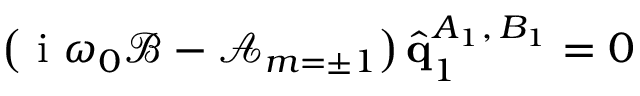Convert formula to latex. <formula><loc_0><loc_0><loc_500><loc_500>\left ( i \omega _ { 0 } \mathcal { B } - \mathcal { A } _ { m = \pm 1 } \right ) \hat { q } _ { 1 } ^ { A _ { 1 } , \, B _ { 1 } } = 0</formula> 